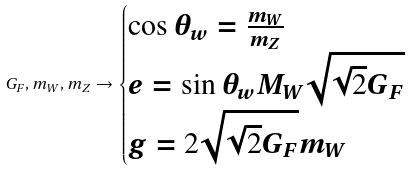<formula> <loc_0><loc_0><loc_500><loc_500>G _ { F } , m _ { W } , m _ { Z } \rightarrow \begin{cases} \cos \theta _ { w } = \frac { m _ { W } } { m _ { Z } } & \\ e = \sin \theta _ { w } M _ { W } \sqrt { \sqrt { 2 } G _ { F } } & \\ g = 2 \sqrt { \sqrt { 2 } G _ { F } } m _ { W } & \end{cases}</formula> 